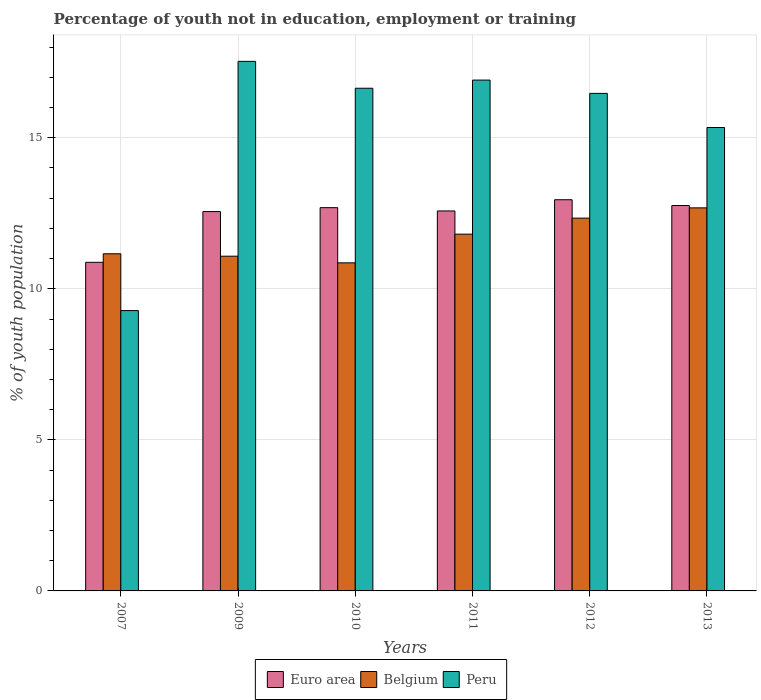How many different coloured bars are there?
Your answer should be compact. 3. Are the number of bars per tick equal to the number of legend labels?
Offer a very short reply. Yes. Are the number of bars on each tick of the X-axis equal?
Your answer should be very brief. Yes. How many bars are there on the 2nd tick from the left?
Your response must be concise. 3. How many bars are there on the 6th tick from the right?
Keep it short and to the point. 3. What is the label of the 3rd group of bars from the left?
Ensure brevity in your answer.  2010. What is the percentage of unemployed youth population in in Belgium in 2010?
Your answer should be very brief. 10.86. Across all years, what is the maximum percentage of unemployed youth population in in Belgium?
Provide a short and direct response. 12.68. Across all years, what is the minimum percentage of unemployed youth population in in Belgium?
Provide a short and direct response. 10.86. In which year was the percentage of unemployed youth population in in Peru maximum?
Your answer should be very brief. 2009. What is the total percentage of unemployed youth population in in Peru in the graph?
Your answer should be very brief. 92.17. What is the difference between the percentage of unemployed youth population in in Peru in 2010 and that in 2013?
Ensure brevity in your answer.  1.3. What is the difference between the percentage of unemployed youth population in in Belgium in 2010 and the percentage of unemployed youth population in in Euro area in 2009?
Offer a terse response. -1.7. What is the average percentage of unemployed youth population in in Belgium per year?
Your response must be concise. 11.66. In the year 2012, what is the difference between the percentage of unemployed youth population in in Euro area and percentage of unemployed youth population in in Peru?
Provide a short and direct response. -3.52. What is the ratio of the percentage of unemployed youth population in in Euro area in 2009 to that in 2010?
Ensure brevity in your answer.  0.99. Is the difference between the percentage of unemployed youth population in in Euro area in 2007 and 2012 greater than the difference between the percentage of unemployed youth population in in Peru in 2007 and 2012?
Your answer should be compact. Yes. What is the difference between the highest and the second highest percentage of unemployed youth population in in Belgium?
Your answer should be very brief. 0.34. What is the difference between the highest and the lowest percentage of unemployed youth population in in Belgium?
Provide a short and direct response. 1.82. What does the 1st bar from the left in 2009 represents?
Your answer should be very brief. Euro area. What does the 3rd bar from the right in 2009 represents?
Your response must be concise. Euro area. Is it the case that in every year, the sum of the percentage of unemployed youth population in in Peru and percentage of unemployed youth population in in Belgium is greater than the percentage of unemployed youth population in in Euro area?
Offer a very short reply. Yes. How many bars are there?
Make the answer very short. 18. Where does the legend appear in the graph?
Make the answer very short. Bottom center. How many legend labels are there?
Provide a succinct answer. 3. How are the legend labels stacked?
Keep it short and to the point. Horizontal. What is the title of the graph?
Make the answer very short. Percentage of youth not in education, employment or training. Does "Jamaica" appear as one of the legend labels in the graph?
Offer a very short reply. No. What is the label or title of the Y-axis?
Provide a succinct answer. % of youth population. What is the % of youth population of Euro area in 2007?
Keep it short and to the point. 10.88. What is the % of youth population of Belgium in 2007?
Make the answer very short. 11.16. What is the % of youth population in Peru in 2007?
Ensure brevity in your answer.  9.28. What is the % of youth population in Euro area in 2009?
Give a very brief answer. 12.56. What is the % of youth population of Belgium in 2009?
Your answer should be very brief. 11.08. What is the % of youth population in Peru in 2009?
Give a very brief answer. 17.53. What is the % of youth population of Euro area in 2010?
Make the answer very short. 12.69. What is the % of youth population in Belgium in 2010?
Offer a terse response. 10.86. What is the % of youth population of Peru in 2010?
Make the answer very short. 16.64. What is the % of youth population in Euro area in 2011?
Your answer should be very brief. 12.58. What is the % of youth population of Belgium in 2011?
Give a very brief answer. 11.81. What is the % of youth population of Peru in 2011?
Provide a short and direct response. 16.91. What is the % of youth population in Euro area in 2012?
Your answer should be compact. 12.95. What is the % of youth population in Belgium in 2012?
Your answer should be compact. 12.34. What is the % of youth population of Peru in 2012?
Make the answer very short. 16.47. What is the % of youth population in Euro area in 2013?
Offer a terse response. 12.76. What is the % of youth population of Belgium in 2013?
Provide a short and direct response. 12.68. What is the % of youth population of Peru in 2013?
Keep it short and to the point. 15.34. Across all years, what is the maximum % of youth population of Euro area?
Make the answer very short. 12.95. Across all years, what is the maximum % of youth population of Belgium?
Provide a short and direct response. 12.68. Across all years, what is the maximum % of youth population of Peru?
Ensure brevity in your answer.  17.53. Across all years, what is the minimum % of youth population in Euro area?
Offer a very short reply. 10.88. Across all years, what is the minimum % of youth population in Belgium?
Your answer should be very brief. 10.86. Across all years, what is the minimum % of youth population of Peru?
Make the answer very short. 9.28. What is the total % of youth population of Euro area in the graph?
Your answer should be compact. 74.41. What is the total % of youth population in Belgium in the graph?
Give a very brief answer. 69.93. What is the total % of youth population in Peru in the graph?
Provide a short and direct response. 92.17. What is the difference between the % of youth population in Euro area in 2007 and that in 2009?
Your response must be concise. -1.68. What is the difference between the % of youth population of Belgium in 2007 and that in 2009?
Make the answer very short. 0.08. What is the difference between the % of youth population of Peru in 2007 and that in 2009?
Provide a succinct answer. -8.25. What is the difference between the % of youth population in Euro area in 2007 and that in 2010?
Your response must be concise. -1.81. What is the difference between the % of youth population in Belgium in 2007 and that in 2010?
Your answer should be very brief. 0.3. What is the difference between the % of youth population in Peru in 2007 and that in 2010?
Your response must be concise. -7.36. What is the difference between the % of youth population of Euro area in 2007 and that in 2011?
Offer a terse response. -1.7. What is the difference between the % of youth population of Belgium in 2007 and that in 2011?
Provide a short and direct response. -0.65. What is the difference between the % of youth population in Peru in 2007 and that in 2011?
Offer a very short reply. -7.63. What is the difference between the % of youth population of Euro area in 2007 and that in 2012?
Your answer should be very brief. -2.07. What is the difference between the % of youth population in Belgium in 2007 and that in 2012?
Your answer should be compact. -1.18. What is the difference between the % of youth population of Peru in 2007 and that in 2012?
Provide a short and direct response. -7.19. What is the difference between the % of youth population in Euro area in 2007 and that in 2013?
Give a very brief answer. -1.88. What is the difference between the % of youth population in Belgium in 2007 and that in 2013?
Give a very brief answer. -1.52. What is the difference between the % of youth population of Peru in 2007 and that in 2013?
Give a very brief answer. -6.06. What is the difference between the % of youth population of Euro area in 2009 and that in 2010?
Offer a terse response. -0.13. What is the difference between the % of youth population in Belgium in 2009 and that in 2010?
Ensure brevity in your answer.  0.22. What is the difference between the % of youth population in Peru in 2009 and that in 2010?
Provide a short and direct response. 0.89. What is the difference between the % of youth population in Euro area in 2009 and that in 2011?
Keep it short and to the point. -0.02. What is the difference between the % of youth population of Belgium in 2009 and that in 2011?
Your answer should be compact. -0.73. What is the difference between the % of youth population of Peru in 2009 and that in 2011?
Give a very brief answer. 0.62. What is the difference between the % of youth population in Euro area in 2009 and that in 2012?
Provide a succinct answer. -0.39. What is the difference between the % of youth population in Belgium in 2009 and that in 2012?
Keep it short and to the point. -1.26. What is the difference between the % of youth population in Peru in 2009 and that in 2012?
Ensure brevity in your answer.  1.06. What is the difference between the % of youth population of Euro area in 2009 and that in 2013?
Give a very brief answer. -0.2. What is the difference between the % of youth population of Peru in 2009 and that in 2013?
Keep it short and to the point. 2.19. What is the difference between the % of youth population in Euro area in 2010 and that in 2011?
Provide a succinct answer. 0.11. What is the difference between the % of youth population of Belgium in 2010 and that in 2011?
Your response must be concise. -0.95. What is the difference between the % of youth population of Peru in 2010 and that in 2011?
Keep it short and to the point. -0.27. What is the difference between the % of youth population of Euro area in 2010 and that in 2012?
Offer a very short reply. -0.26. What is the difference between the % of youth population in Belgium in 2010 and that in 2012?
Keep it short and to the point. -1.48. What is the difference between the % of youth population of Peru in 2010 and that in 2012?
Your response must be concise. 0.17. What is the difference between the % of youth population in Euro area in 2010 and that in 2013?
Your response must be concise. -0.07. What is the difference between the % of youth population in Belgium in 2010 and that in 2013?
Your answer should be very brief. -1.82. What is the difference between the % of youth population of Euro area in 2011 and that in 2012?
Make the answer very short. -0.37. What is the difference between the % of youth population of Belgium in 2011 and that in 2012?
Give a very brief answer. -0.53. What is the difference between the % of youth population in Peru in 2011 and that in 2012?
Provide a short and direct response. 0.44. What is the difference between the % of youth population in Euro area in 2011 and that in 2013?
Give a very brief answer. -0.18. What is the difference between the % of youth population of Belgium in 2011 and that in 2013?
Your response must be concise. -0.87. What is the difference between the % of youth population of Peru in 2011 and that in 2013?
Give a very brief answer. 1.57. What is the difference between the % of youth population of Euro area in 2012 and that in 2013?
Make the answer very short. 0.19. What is the difference between the % of youth population in Belgium in 2012 and that in 2013?
Make the answer very short. -0.34. What is the difference between the % of youth population in Peru in 2012 and that in 2013?
Provide a succinct answer. 1.13. What is the difference between the % of youth population in Euro area in 2007 and the % of youth population in Belgium in 2009?
Offer a very short reply. -0.2. What is the difference between the % of youth population of Euro area in 2007 and the % of youth population of Peru in 2009?
Your answer should be very brief. -6.65. What is the difference between the % of youth population of Belgium in 2007 and the % of youth population of Peru in 2009?
Keep it short and to the point. -6.37. What is the difference between the % of youth population of Euro area in 2007 and the % of youth population of Belgium in 2010?
Provide a short and direct response. 0.02. What is the difference between the % of youth population in Euro area in 2007 and the % of youth population in Peru in 2010?
Keep it short and to the point. -5.76. What is the difference between the % of youth population in Belgium in 2007 and the % of youth population in Peru in 2010?
Ensure brevity in your answer.  -5.48. What is the difference between the % of youth population in Euro area in 2007 and the % of youth population in Belgium in 2011?
Make the answer very short. -0.93. What is the difference between the % of youth population in Euro area in 2007 and the % of youth population in Peru in 2011?
Make the answer very short. -6.03. What is the difference between the % of youth population of Belgium in 2007 and the % of youth population of Peru in 2011?
Provide a succinct answer. -5.75. What is the difference between the % of youth population in Euro area in 2007 and the % of youth population in Belgium in 2012?
Offer a terse response. -1.46. What is the difference between the % of youth population of Euro area in 2007 and the % of youth population of Peru in 2012?
Ensure brevity in your answer.  -5.59. What is the difference between the % of youth population in Belgium in 2007 and the % of youth population in Peru in 2012?
Your answer should be compact. -5.31. What is the difference between the % of youth population of Euro area in 2007 and the % of youth population of Belgium in 2013?
Offer a very short reply. -1.8. What is the difference between the % of youth population of Euro area in 2007 and the % of youth population of Peru in 2013?
Ensure brevity in your answer.  -4.46. What is the difference between the % of youth population of Belgium in 2007 and the % of youth population of Peru in 2013?
Make the answer very short. -4.18. What is the difference between the % of youth population of Euro area in 2009 and the % of youth population of Belgium in 2010?
Offer a terse response. 1.7. What is the difference between the % of youth population of Euro area in 2009 and the % of youth population of Peru in 2010?
Your response must be concise. -4.08. What is the difference between the % of youth population of Belgium in 2009 and the % of youth population of Peru in 2010?
Give a very brief answer. -5.56. What is the difference between the % of youth population in Euro area in 2009 and the % of youth population in Belgium in 2011?
Your answer should be very brief. 0.75. What is the difference between the % of youth population of Euro area in 2009 and the % of youth population of Peru in 2011?
Provide a succinct answer. -4.35. What is the difference between the % of youth population of Belgium in 2009 and the % of youth population of Peru in 2011?
Make the answer very short. -5.83. What is the difference between the % of youth population in Euro area in 2009 and the % of youth population in Belgium in 2012?
Make the answer very short. 0.22. What is the difference between the % of youth population in Euro area in 2009 and the % of youth population in Peru in 2012?
Keep it short and to the point. -3.91. What is the difference between the % of youth population of Belgium in 2009 and the % of youth population of Peru in 2012?
Your response must be concise. -5.39. What is the difference between the % of youth population of Euro area in 2009 and the % of youth population of Belgium in 2013?
Keep it short and to the point. -0.12. What is the difference between the % of youth population in Euro area in 2009 and the % of youth population in Peru in 2013?
Your answer should be very brief. -2.78. What is the difference between the % of youth population in Belgium in 2009 and the % of youth population in Peru in 2013?
Ensure brevity in your answer.  -4.26. What is the difference between the % of youth population in Euro area in 2010 and the % of youth population in Belgium in 2011?
Offer a very short reply. 0.88. What is the difference between the % of youth population of Euro area in 2010 and the % of youth population of Peru in 2011?
Your answer should be compact. -4.22. What is the difference between the % of youth population of Belgium in 2010 and the % of youth population of Peru in 2011?
Ensure brevity in your answer.  -6.05. What is the difference between the % of youth population in Euro area in 2010 and the % of youth population in Belgium in 2012?
Keep it short and to the point. 0.35. What is the difference between the % of youth population of Euro area in 2010 and the % of youth population of Peru in 2012?
Your answer should be very brief. -3.78. What is the difference between the % of youth population in Belgium in 2010 and the % of youth population in Peru in 2012?
Your response must be concise. -5.61. What is the difference between the % of youth population of Euro area in 2010 and the % of youth population of Belgium in 2013?
Offer a very short reply. 0.01. What is the difference between the % of youth population of Euro area in 2010 and the % of youth population of Peru in 2013?
Give a very brief answer. -2.65. What is the difference between the % of youth population in Belgium in 2010 and the % of youth population in Peru in 2013?
Make the answer very short. -4.48. What is the difference between the % of youth population of Euro area in 2011 and the % of youth population of Belgium in 2012?
Ensure brevity in your answer.  0.24. What is the difference between the % of youth population of Euro area in 2011 and the % of youth population of Peru in 2012?
Offer a very short reply. -3.89. What is the difference between the % of youth population of Belgium in 2011 and the % of youth population of Peru in 2012?
Give a very brief answer. -4.66. What is the difference between the % of youth population of Euro area in 2011 and the % of youth population of Belgium in 2013?
Your answer should be very brief. -0.1. What is the difference between the % of youth population of Euro area in 2011 and the % of youth population of Peru in 2013?
Your answer should be compact. -2.76. What is the difference between the % of youth population in Belgium in 2011 and the % of youth population in Peru in 2013?
Offer a terse response. -3.53. What is the difference between the % of youth population in Euro area in 2012 and the % of youth population in Belgium in 2013?
Ensure brevity in your answer.  0.27. What is the difference between the % of youth population of Euro area in 2012 and the % of youth population of Peru in 2013?
Offer a terse response. -2.39. What is the difference between the % of youth population in Belgium in 2012 and the % of youth population in Peru in 2013?
Offer a very short reply. -3. What is the average % of youth population of Euro area per year?
Provide a short and direct response. 12.4. What is the average % of youth population in Belgium per year?
Your response must be concise. 11.65. What is the average % of youth population of Peru per year?
Your response must be concise. 15.36. In the year 2007, what is the difference between the % of youth population of Euro area and % of youth population of Belgium?
Your answer should be compact. -0.28. In the year 2007, what is the difference between the % of youth population in Euro area and % of youth population in Peru?
Keep it short and to the point. 1.6. In the year 2007, what is the difference between the % of youth population of Belgium and % of youth population of Peru?
Offer a very short reply. 1.88. In the year 2009, what is the difference between the % of youth population in Euro area and % of youth population in Belgium?
Your answer should be very brief. 1.48. In the year 2009, what is the difference between the % of youth population of Euro area and % of youth population of Peru?
Give a very brief answer. -4.97. In the year 2009, what is the difference between the % of youth population in Belgium and % of youth population in Peru?
Keep it short and to the point. -6.45. In the year 2010, what is the difference between the % of youth population in Euro area and % of youth population in Belgium?
Provide a succinct answer. 1.83. In the year 2010, what is the difference between the % of youth population in Euro area and % of youth population in Peru?
Ensure brevity in your answer.  -3.95. In the year 2010, what is the difference between the % of youth population of Belgium and % of youth population of Peru?
Provide a succinct answer. -5.78. In the year 2011, what is the difference between the % of youth population in Euro area and % of youth population in Belgium?
Your answer should be compact. 0.77. In the year 2011, what is the difference between the % of youth population of Euro area and % of youth population of Peru?
Your answer should be compact. -4.33. In the year 2011, what is the difference between the % of youth population in Belgium and % of youth population in Peru?
Give a very brief answer. -5.1. In the year 2012, what is the difference between the % of youth population of Euro area and % of youth population of Belgium?
Keep it short and to the point. 0.61. In the year 2012, what is the difference between the % of youth population of Euro area and % of youth population of Peru?
Make the answer very short. -3.52. In the year 2012, what is the difference between the % of youth population in Belgium and % of youth population in Peru?
Offer a terse response. -4.13. In the year 2013, what is the difference between the % of youth population of Euro area and % of youth population of Belgium?
Keep it short and to the point. 0.08. In the year 2013, what is the difference between the % of youth population of Euro area and % of youth population of Peru?
Provide a succinct answer. -2.58. In the year 2013, what is the difference between the % of youth population in Belgium and % of youth population in Peru?
Make the answer very short. -2.66. What is the ratio of the % of youth population in Euro area in 2007 to that in 2009?
Make the answer very short. 0.87. What is the ratio of the % of youth population in Belgium in 2007 to that in 2009?
Keep it short and to the point. 1.01. What is the ratio of the % of youth population in Peru in 2007 to that in 2009?
Make the answer very short. 0.53. What is the ratio of the % of youth population in Euro area in 2007 to that in 2010?
Your response must be concise. 0.86. What is the ratio of the % of youth population of Belgium in 2007 to that in 2010?
Offer a very short reply. 1.03. What is the ratio of the % of youth population in Peru in 2007 to that in 2010?
Ensure brevity in your answer.  0.56. What is the ratio of the % of youth population of Euro area in 2007 to that in 2011?
Your answer should be very brief. 0.86. What is the ratio of the % of youth population of Belgium in 2007 to that in 2011?
Your answer should be compact. 0.94. What is the ratio of the % of youth population in Peru in 2007 to that in 2011?
Provide a succinct answer. 0.55. What is the ratio of the % of youth population in Euro area in 2007 to that in 2012?
Your response must be concise. 0.84. What is the ratio of the % of youth population of Belgium in 2007 to that in 2012?
Offer a very short reply. 0.9. What is the ratio of the % of youth population of Peru in 2007 to that in 2012?
Keep it short and to the point. 0.56. What is the ratio of the % of youth population in Euro area in 2007 to that in 2013?
Your answer should be compact. 0.85. What is the ratio of the % of youth population of Belgium in 2007 to that in 2013?
Your answer should be very brief. 0.88. What is the ratio of the % of youth population in Peru in 2007 to that in 2013?
Provide a succinct answer. 0.6. What is the ratio of the % of youth population of Euro area in 2009 to that in 2010?
Give a very brief answer. 0.99. What is the ratio of the % of youth population in Belgium in 2009 to that in 2010?
Provide a short and direct response. 1.02. What is the ratio of the % of youth population in Peru in 2009 to that in 2010?
Your answer should be compact. 1.05. What is the ratio of the % of youth population in Euro area in 2009 to that in 2011?
Give a very brief answer. 1. What is the ratio of the % of youth population of Belgium in 2009 to that in 2011?
Provide a short and direct response. 0.94. What is the ratio of the % of youth population in Peru in 2009 to that in 2011?
Make the answer very short. 1.04. What is the ratio of the % of youth population of Euro area in 2009 to that in 2012?
Keep it short and to the point. 0.97. What is the ratio of the % of youth population of Belgium in 2009 to that in 2012?
Provide a short and direct response. 0.9. What is the ratio of the % of youth population in Peru in 2009 to that in 2012?
Make the answer very short. 1.06. What is the ratio of the % of youth population in Euro area in 2009 to that in 2013?
Provide a short and direct response. 0.98. What is the ratio of the % of youth population in Belgium in 2009 to that in 2013?
Your answer should be compact. 0.87. What is the ratio of the % of youth population of Peru in 2009 to that in 2013?
Your answer should be compact. 1.14. What is the ratio of the % of youth population of Euro area in 2010 to that in 2011?
Give a very brief answer. 1.01. What is the ratio of the % of youth population in Belgium in 2010 to that in 2011?
Your response must be concise. 0.92. What is the ratio of the % of youth population in Euro area in 2010 to that in 2012?
Ensure brevity in your answer.  0.98. What is the ratio of the % of youth population in Belgium in 2010 to that in 2012?
Make the answer very short. 0.88. What is the ratio of the % of youth population of Peru in 2010 to that in 2012?
Offer a very short reply. 1.01. What is the ratio of the % of youth population of Euro area in 2010 to that in 2013?
Provide a short and direct response. 0.99. What is the ratio of the % of youth population in Belgium in 2010 to that in 2013?
Your response must be concise. 0.86. What is the ratio of the % of youth population in Peru in 2010 to that in 2013?
Your answer should be very brief. 1.08. What is the ratio of the % of youth population of Euro area in 2011 to that in 2012?
Your answer should be compact. 0.97. What is the ratio of the % of youth population of Belgium in 2011 to that in 2012?
Provide a short and direct response. 0.96. What is the ratio of the % of youth population of Peru in 2011 to that in 2012?
Provide a short and direct response. 1.03. What is the ratio of the % of youth population of Euro area in 2011 to that in 2013?
Provide a succinct answer. 0.99. What is the ratio of the % of youth population in Belgium in 2011 to that in 2013?
Your answer should be compact. 0.93. What is the ratio of the % of youth population of Peru in 2011 to that in 2013?
Provide a succinct answer. 1.1. What is the ratio of the % of youth population of Belgium in 2012 to that in 2013?
Your answer should be very brief. 0.97. What is the ratio of the % of youth population in Peru in 2012 to that in 2013?
Provide a short and direct response. 1.07. What is the difference between the highest and the second highest % of youth population in Euro area?
Make the answer very short. 0.19. What is the difference between the highest and the second highest % of youth population of Belgium?
Your answer should be compact. 0.34. What is the difference between the highest and the second highest % of youth population of Peru?
Your response must be concise. 0.62. What is the difference between the highest and the lowest % of youth population of Euro area?
Give a very brief answer. 2.07. What is the difference between the highest and the lowest % of youth population in Belgium?
Your answer should be compact. 1.82. What is the difference between the highest and the lowest % of youth population of Peru?
Ensure brevity in your answer.  8.25. 